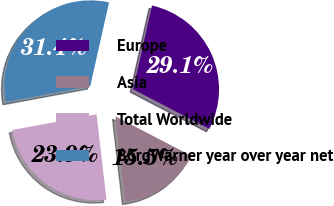<chart> <loc_0><loc_0><loc_500><loc_500><pie_chart><fcel>Europe<fcel>Asia<fcel>Total Worldwide<fcel>BorgWarner year over year net<nl><fcel>29.11%<fcel>15.52%<fcel>23.93%<fcel>31.44%<nl></chart> 